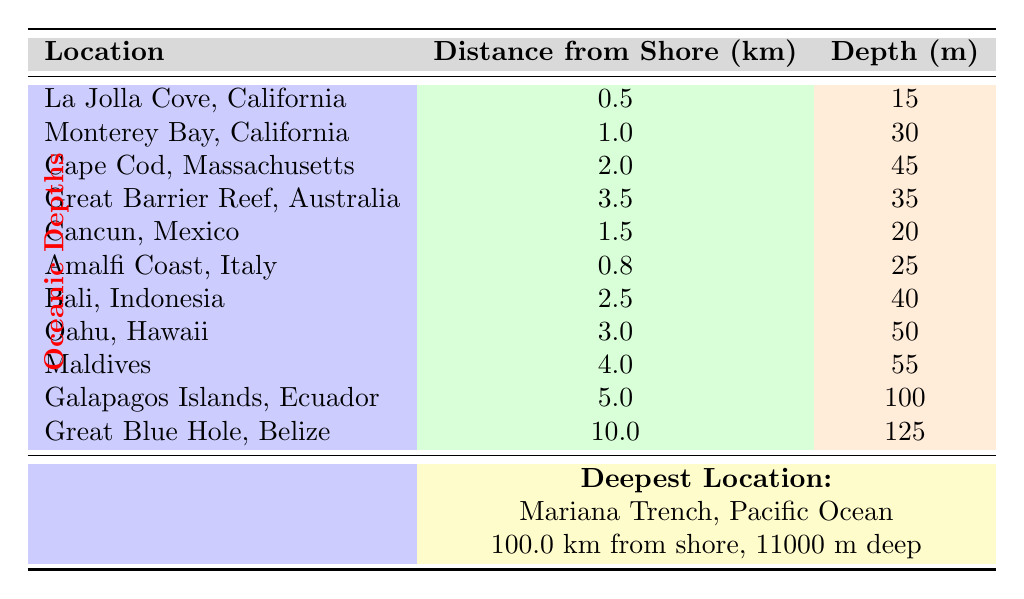What is the depth at La Jolla Cove, California? The table shows that the depth listed for La Jolla Cove, California is 15 meters.
Answer: 15 m Which location is the deepest in the table? The deepest location listed in the table is the Mariana Trench, Pacific Ocean, with a depth of 11,000 meters.
Answer: Mariana Trench How far is the Great Barrier Reef from the shore? According to the table, the Great Barrier Reef is 3.5 kilometers from the shore.
Answer: 3.5 km What is the average depth of the locations listed in the table? To find the average depth, first add all depths: 15 + 30 + 45 + 35 + 20 + 25 + 40 + 50 + 55 + 100 + 125 + 11000 = 11155 meters. Then divide by the number of locations (12), which equals approximately 929.58 meters.
Answer: 929.58 m Is the depth at Cancun greater than 30 meters? The depth at Cancun is 20 meters, which is not greater than 30 meters.
Answer: No What is the difference in depth between the Maldives and Oahu, Hawaii? The depth at the Maldives is 55 meters, and at Oahu, Hawaii it is 50 meters. The difference is 55 - 50 = 5 meters.
Answer: 5 m If you combine the distances of La Jolla Cove and Monterey Bay, what distance do you get? The distance from La Jolla Cove is 0.5 km and Monterey Bay is 1.0 km. Adding them gives 0.5 + 1.0 = 1.5 kilometers.
Answer: 1.5 km What is the minimum depth recorded in this table? By checking all the depths, the minimum is found to be at La Jolla Cove, California, with a depth of 15 meters.
Answer: 15 m Which two locations have depths below 40 meters? The locations with depths below 40 meters are La Jolla Cove, California (15 m), Cancun, Mexico (20 m), and Great Barrier Reef, Australia (35 m).
Answer: La Jolla Cove, Cancun, and Great Barrier Reef What is the total distance from the shore for the two deepest locations listed? The two deepest locations are the Mariana Trench (100 km) and Great Blue Hole (10 km). The total distance is 100 + 10 = 110 kilometers.
Answer: 110 km 